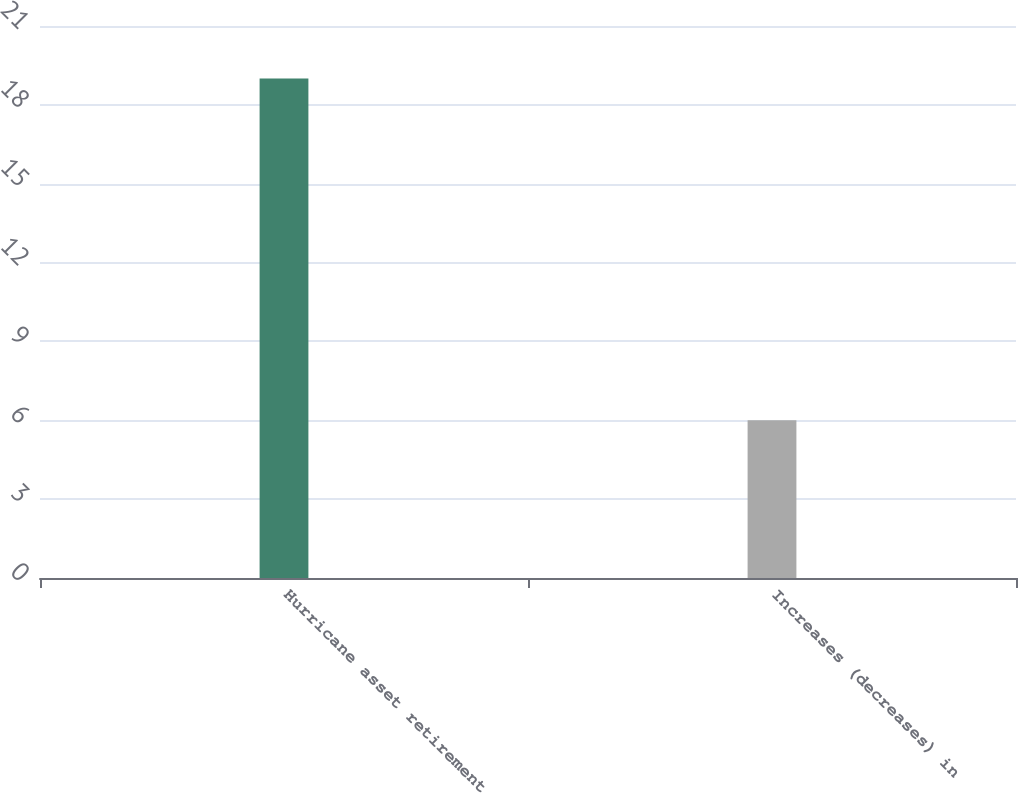<chart> <loc_0><loc_0><loc_500><loc_500><bar_chart><fcel>Hurricane asset retirement<fcel>Increases (decreases) in<nl><fcel>19<fcel>6<nl></chart> 